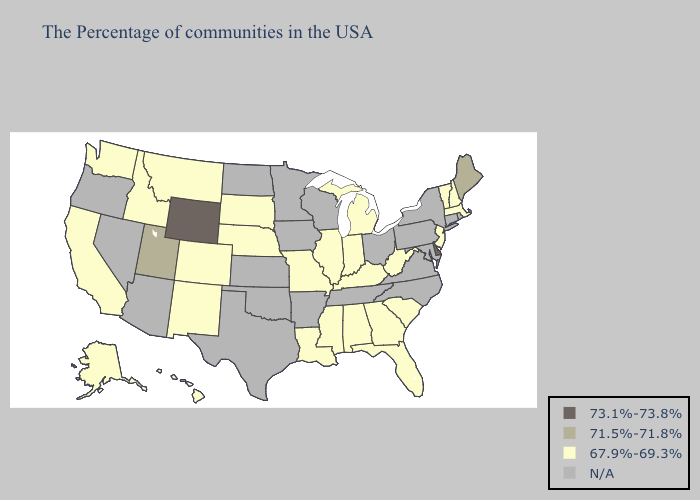Does Delaware have the lowest value in the South?
Answer briefly. No. Name the states that have a value in the range N/A?
Keep it brief. Rhode Island, Connecticut, New York, Maryland, Pennsylvania, Virginia, North Carolina, Ohio, Tennessee, Wisconsin, Arkansas, Minnesota, Iowa, Kansas, Oklahoma, Texas, North Dakota, Arizona, Nevada, Oregon. Name the states that have a value in the range 73.1%-73.8%?
Concise answer only. Delaware, Wyoming. Which states have the lowest value in the South?
Short answer required. South Carolina, West Virginia, Florida, Georgia, Kentucky, Alabama, Mississippi, Louisiana. What is the value of Arkansas?
Give a very brief answer. N/A. Name the states that have a value in the range 73.1%-73.8%?
Answer briefly. Delaware, Wyoming. What is the lowest value in states that border Indiana?
Write a very short answer. 67.9%-69.3%. What is the highest value in states that border Idaho?
Keep it brief. 73.1%-73.8%. What is the highest value in the USA?
Answer briefly. 73.1%-73.8%. Which states have the lowest value in the USA?
Answer briefly. Massachusetts, New Hampshire, Vermont, New Jersey, South Carolina, West Virginia, Florida, Georgia, Michigan, Kentucky, Indiana, Alabama, Illinois, Mississippi, Louisiana, Missouri, Nebraska, South Dakota, Colorado, New Mexico, Montana, Idaho, California, Washington, Alaska, Hawaii. Name the states that have a value in the range 67.9%-69.3%?
Quick response, please. Massachusetts, New Hampshire, Vermont, New Jersey, South Carolina, West Virginia, Florida, Georgia, Michigan, Kentucky, Indiana, Alabama, Illinois, Mississippi, Louisiana, Missouri, Nebraska, South Dakota, Colorado, New Mexico, Montana, Idaho, California, Washington, Alaska, Hawaii. Among the states that border Texas , which have the lowest value?
Write a very short answer. Louisiana, New Mexico. What is the value of Utah?
Quick response, please. 71.5%-71.8%. Among the states that border Oklahoma , which have the highest value?
Answer briefly. Missouri, Colorado, New Mexico. 